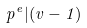Convert formula to latex. <formula><loc_0><loc_0><loc_500><loc_500>p ^ { e } | ( v - 1 )</formula> 